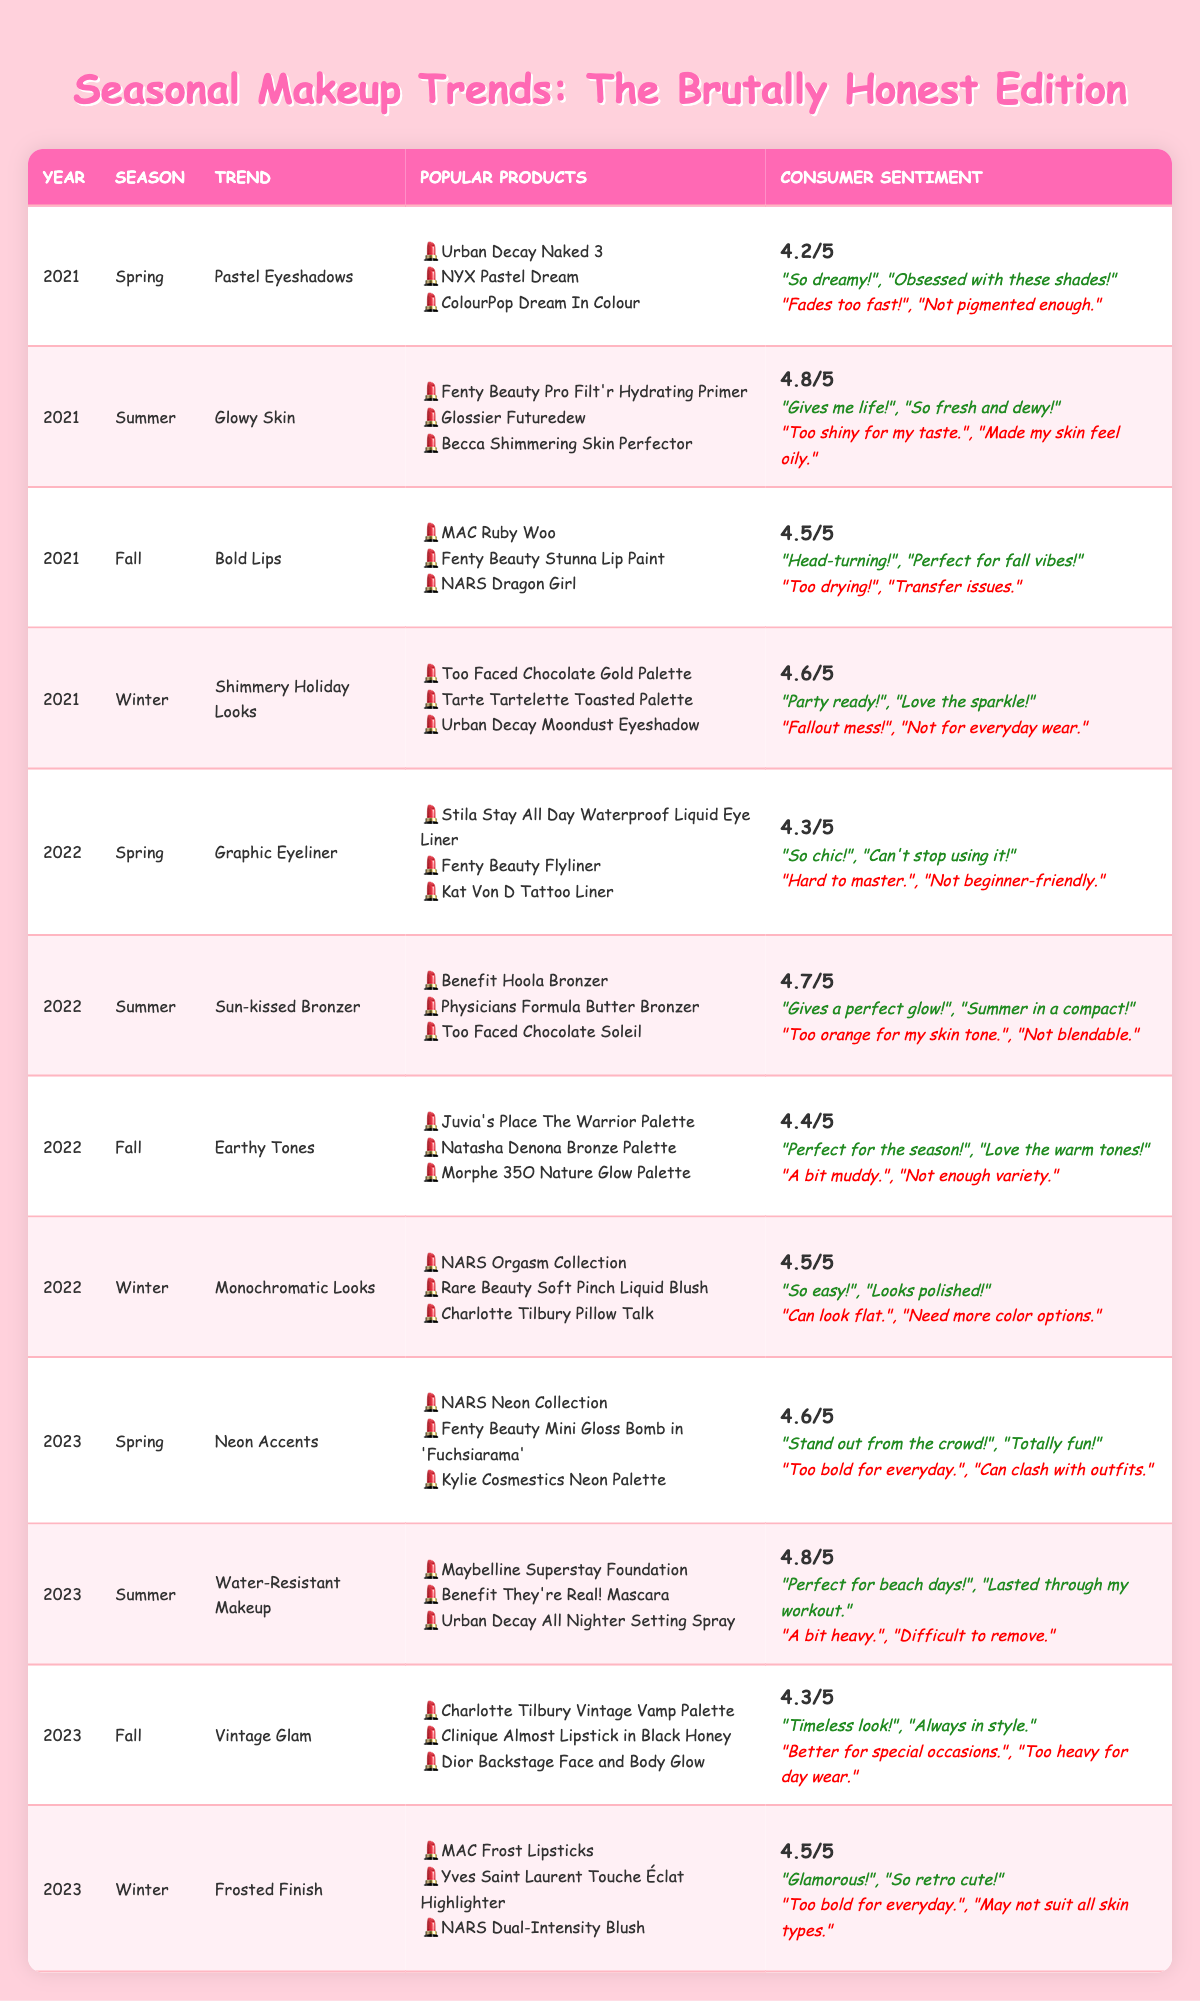What's the overall rating for the Summer trend in 2022? By looking at the table, for Summer 2022, the trend is "Sun-kissed Bronzer," and the overall rating given is 4.7.
Answer: 4.7 Which season had the highest overall rating in 2021? In the table, the ratings for each season in 2021 are: Spring (4.2), Summer (4.8), Fall (4.5), and Winter (4.6). The highest rating is for Summer at 4.8.
Answer: Summer What are the popular products listed for the Fall trend in 2023? The table indicates that for Fall 2023, the trend is "Vintage Glam," and the popular products listed are: "Charlotte Tilbury Vintage Vamp Palette," "Clinique Almost Lipstick in Black Honey," and "Dior Backstage Face and Body Glow."
Answer: Charlotte Tilbury Vintage Vamp Palette, Clinique Almost Lipstick in Black Honey, Dior Backstage Face and Body Glow Did any trend in Winter 2022 have negative comments about being too bold? The Winter 2022 trend, "Monochromatic Looks," shows negative comments of "Can look flat" and "Need more color options," which do not pertain to being too bold. Therefore, the answer is no.
Answer: No What's the average overall rating for Summer across the years 2021, 2022, and 2023? From the table, Summer ratings are: 2021 (4.8), 2022 (4.7), and 2023 (4.8). The average is calculated as (4.8 + 4.7 + 4.8) / 3 = 4.767, which rounds to 4.77.
Answer: 4.77 For the Spring trend in 2023, how do the positive comments compare to the negative ones? The Spring 2023 trend is "Neon Accents." The positive comments are "Stand out from the crowd!" and "Totally fun!" while the negative comments are "Too bold for everyday" and "Can clash with outfits." There are two positive comments and two negative comments, indicating they are equal.
Answer: They are equal What was the consumer sentiment for the Winter trend in 2021? The Winter 2021 trend is "Shimmery Holiday Looks." The overall rating is 4.6, with positive comments: "Party ready!" and "Love the sparkle!" and negative comments: "Fallout mess!" and "Not for everyday wear."
Answer: Overall rating 4.6, positive: 2, negative: 2 Which trend received complaints about being "too shiny" and in what year? In the table, the trend "Glowy Skin" from Summer 2021 received a negative comment of "Too shiny for my taste." Thus, that is the specific trend with complaints about shininess.
Answer: Glowy Skin, 2021 What is the trend for Fall 2022 and its overall rating? According to the table, the trend for Fall 2022 is "Earthy Tones," and its overall rating is 4.4.
Answer: Earthy Tones, 4.4 How many trends in 2022 had an overall rating of 4.5 or higher? Looking at the table, the following trends from 2022 have ratings of 4.5 or higher: Spring (4.3), Summer (4.7), Fall (4.4), and Winter (4.5), making a total of three trends with ratings of 4.5 or higher.
Answer: Three trends Which season showed the lowest overall rating in 2023? In 2023, the lowest overall rating is 4.3 for the Fall trend "Vintage Glam." All other seasons have higher ratings: Spring (4.6), Summer (4.8), Winter (4.5).
Answer: Fall 2023 